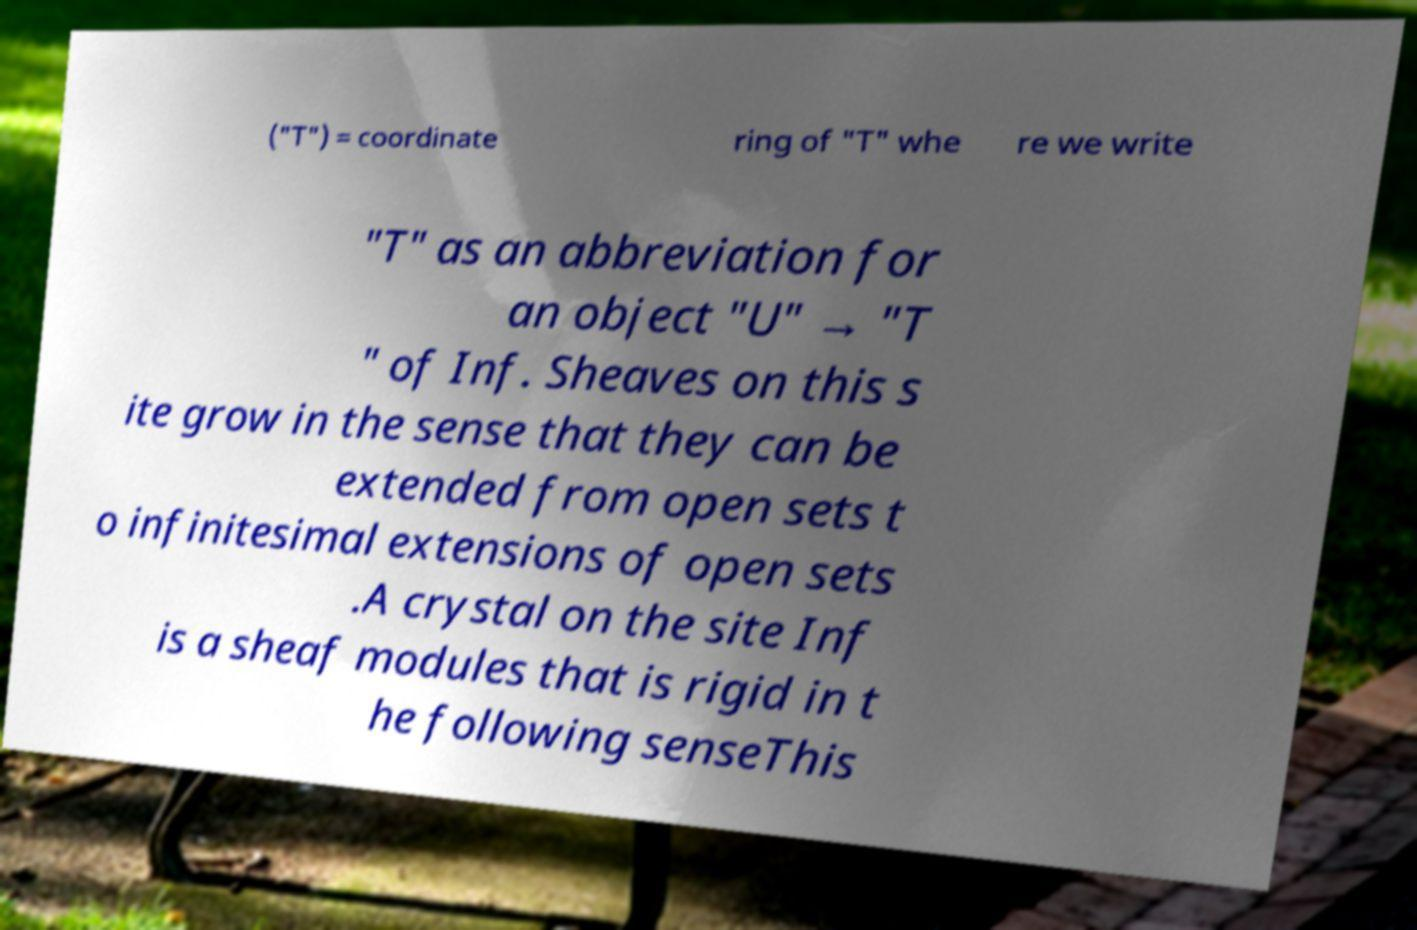Please read and relay the text visible in this image. What does it say? ("T") = coordinate ring of "T" whe re we write "T" as an abbreviation for an object "U" → "T " of Inf. Sheaves on this s ite grow in the sense that they can be extended from open sets t o infinitesimal extensions of open sets .A crystal on the site Inf is a sheaf modules that is rigid in t he following senseThis 